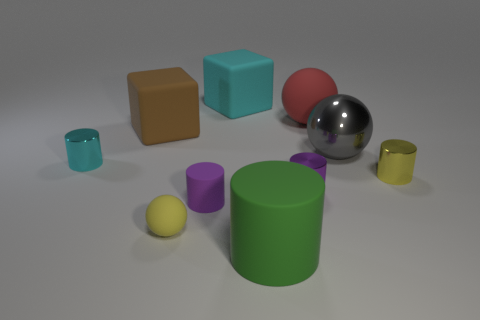Is there a large red object right of the cyan shiny object that is in front of the brown block?
Give a very brief answer. Yes. Are there the same number of large red things that are right of the small yellow shiny cylinder and large gray rubber objects?
Your response must be concise. Yes. What number of other objects are the same size as the cyan cylinder?
Keep it short and to the point. 4. Does the small cylinder on the left side of the yellow matte sphere have the same material as the tiny purple cylinder that is to the right of the green thing?
Your answer should be very brief. Yes. There is a rubber sphere in front of the rubber ball that is behind the brown rubber cube; what is its size?
Provide a short and direct response. Small. Are there any matte cylinders of the same color as the big shiny thing?
Provide a short and direct response. No. Does the matte sphere left of the big rubber cylinder have the same color as the thing that is right of the big gray sphere?
Provide a short and direct response. Yes. There is a large gray metallic object; what shape is it?
Your answer should be compact. Sphere. There is a tiny yellow rubber ball; how many green objects are behind it?
Offer a terse response. 0. What number of gray things have the same material as the tiny yellow ball?
Offer a terse response. 0. 